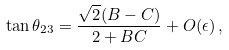Convert formula to latex. <formula><loc_0><loc_0><loc_500><loc_500>\tan \theta _ { 2 3 } = \frac { \sqrt { 2 } ( B - C ) } { 2 + B C } + O ( \epsilon ) \, ,</formula> 